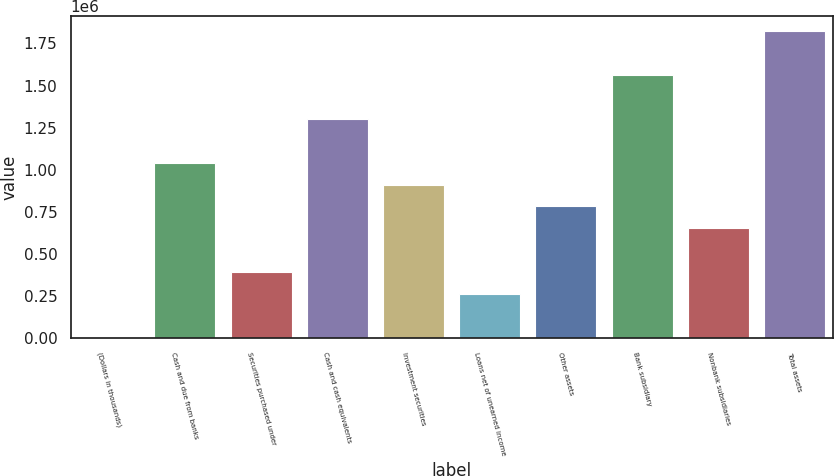<chart> <loc_0><loc_0><loc_500><loc_500><bar_chart><fcel>(Dollars in thousands)<fcel>Cash and due from banks<fcel>Securities purchased under<fcel>Cash and cash equivalents<fcel>Investment securities<fcel>Loans net of unearned income<fcel>Other assets<fcel>Bank subsidiary<fcel>Nonbank subsidiaries<fcel>Total assets<nl><fcel>2008<fcel>1.04274e+06<fcel>392282<fcel>1.30292e+06<fcel>912647<fcel>262191<fcel>782556<fcel>1.5631e+06<fcel>652464<fcel>1.82329e+06<nl></chart> 